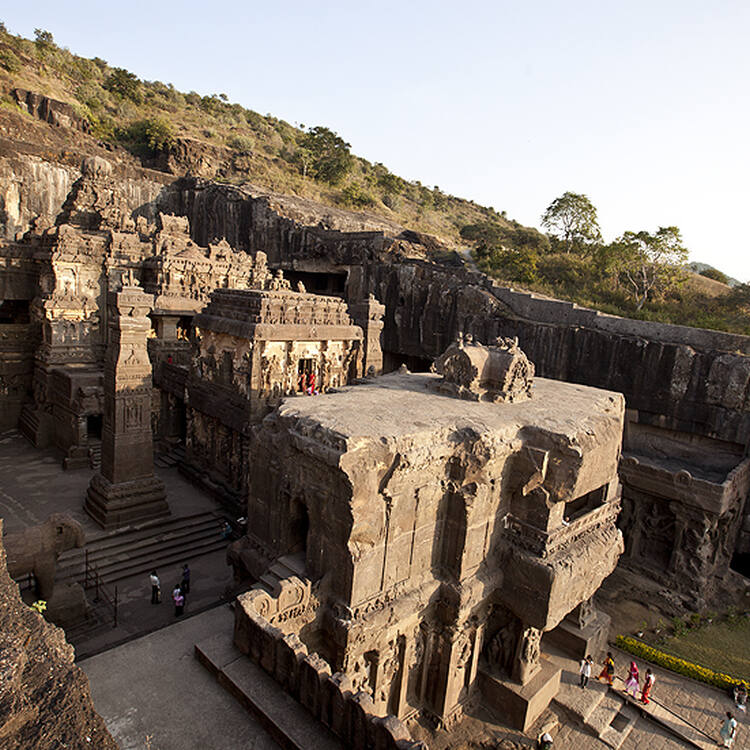Imagine a mystical event happened in Ellora Caves that changed history. What could the event be? Imagine that one night, under a full moon, the carvings of the Ellora Caves came to life. The deities, animals, and mythical creatures depicted in the stone sculptures emerged from the rock and began to interact with the astonished visitors. The event, witnessed by monks, scholars, and locals, resulted in a profound spiritual revival, bridging ancient wisdom with contemporary life. News of the miraculous event spread worldwide, attracting pilgrims, historians, and tourists, reigniting a global interest in ancient Indian heritage and leading to a new era of cultural renaissance. 